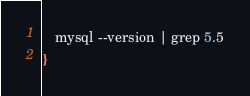<code> <loc_0><loc_0><loc_500><loc_500><_Bash_>   mysql --version | grep 5.5
}
</code> 